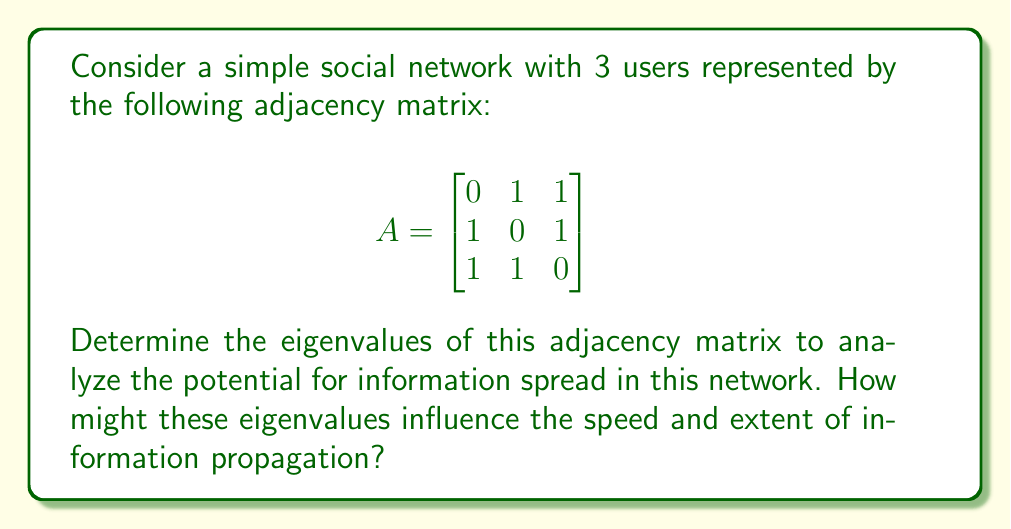Solve this math problem. To find the eigenvalues of the adjacency matrix A, we need to solve the characteristic equation:

$$\det(A - \lambda I) = 0$$

Where $I$ is the 3x3 identity matrix and $\lambda$ represents the eigenvalues.

Step 1: Set up the characteristic equation:

$$\det\begin{pmatrix}
-\lambda & 1 & 1 \\
1 & -\lambda & 1 \\
1 & 1 & -\lambda
\end{pmatrix} = 0$$

Step 2: Calculate the determinant:

$$(-\lambda)(-\lambda)(-\lambda) + (1)(1)(1) + (1)(1)(1) - (1)(1)(-\lambda) - (1)(1)(-\lambda) - (-\lambda)(1)(1) = 0$$

Step 3: Simplify the equation:

$$-\lambda^3 + 2 - 3\lambda = 0$$
$$-\lambda^3 - 3\lambda + 2 = 0$$

Step 4: Factor the equation:

$$-(\lambda + 2)(\lambda - 1)^2 = 0$$

Step 5: Solve for $\lambda$:

$$\lambda = -2 \text{ or } \lambda = 1 \text{ (with multiplicity 2)}$$

The eigenvalues are -2 and 1 (twice). 

Interpretation:
1. The largest eigenvalue (1) represents the growth rate of information spread in the network. A positive value indicates that information can propagate effectively.
2. The multiplicity of the largest eigenvalue (2) suggests that there are multiple dominant pathways for information flow.
3. The negative eigenvalue (-2) indicates some oscillatory behavior in the network, which might lead to some information cancellation or interference.

In the context of a tech company, these eigenvalues suggest that information (e.g., product announcements or company news) would spread quickly and efficiently through this small network, potentially reaching all users rapidly due to the high connectivity.
Answer: Eigenvalues: -2, 1 (multiplicity 2) 